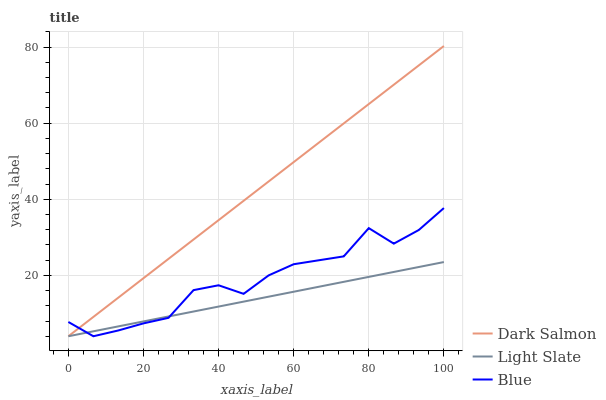Does Light Slate have the minimum area under the curve?
Answer yes or no. Yes. Does Dark Salmon have the maximum area under the curve?
Answer yes or no. Yes. Does Blue have the minimum area under the curve?
Answer yes or no. No. Does Blue have the maximum area under the curve?
Answer yes or no. No. Is Light Slate the smoothest?
Answer yes or no. Yes. Is Blue the roughest?
Answer yes or no. Yes. Is Dark Salmon the smoothest?
Answer yes or no. No. Is Dark Salmon the roughest?
Answer yes or no. No. Does Dark Salmon have the highest value?
Answer yes or no. Yes. Does Blue have the highest value?
Answer yes or no. No. 